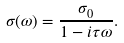<formula> <loc_0><loc_0><loc_500><loc_500>\sigma ( \omega ) = \frac { \sigma _ { 0 } } { 1 - i \tau \omega } .</formula> 